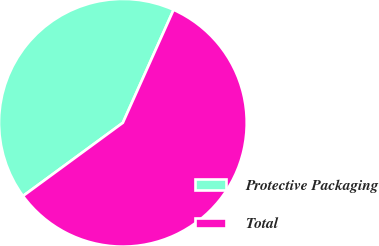Convert chart. <chart><loc_0><loc_0><loc_500><loc_500><pie_chart><fcel>Protective Packaging<fcel>Total<nl><fcel>41.79%<fcel>58.21%<nl></chart> 